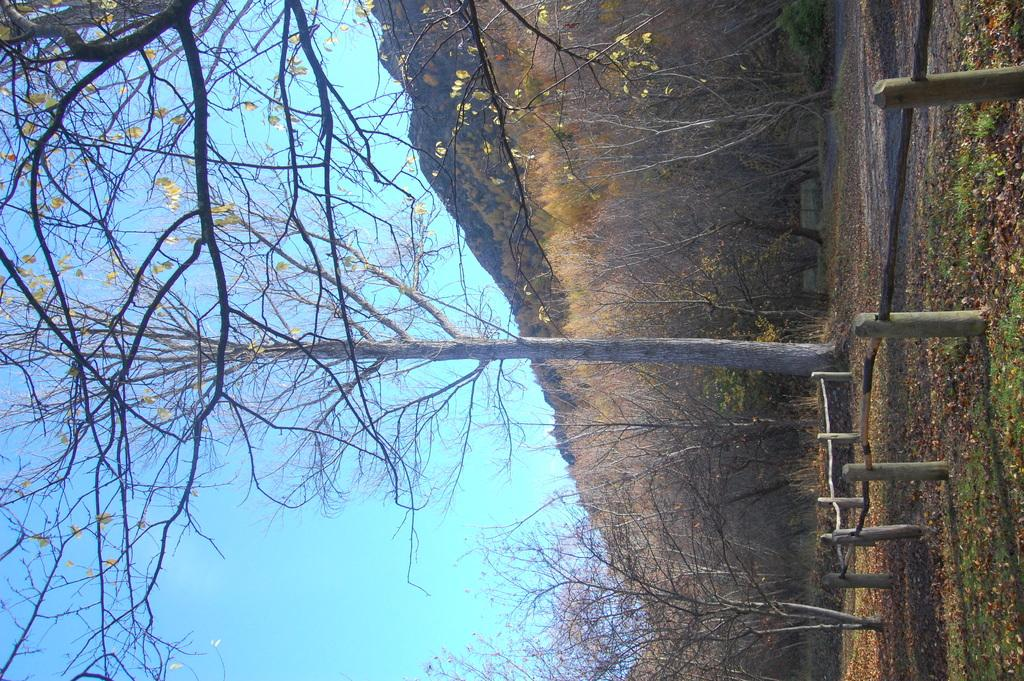What type of vegetation can be seen in the image? There are dried trees in the image. What is on the ground in the image? There is grass on the ground in the image. What can be seen in the distance in the image? There are hills visible in the background of the image. What is visible above the hills in the image? The sky is visible in the background of the image. Can you tell me how many people are talking about their regrets in the image? There are no people present in the image, and therefore no conversations or regrets can be observed. What type of bubble is floating in the sky in the image? There is no bubble present in the image; only dried trees, grass, hills, and the sky are visible. 